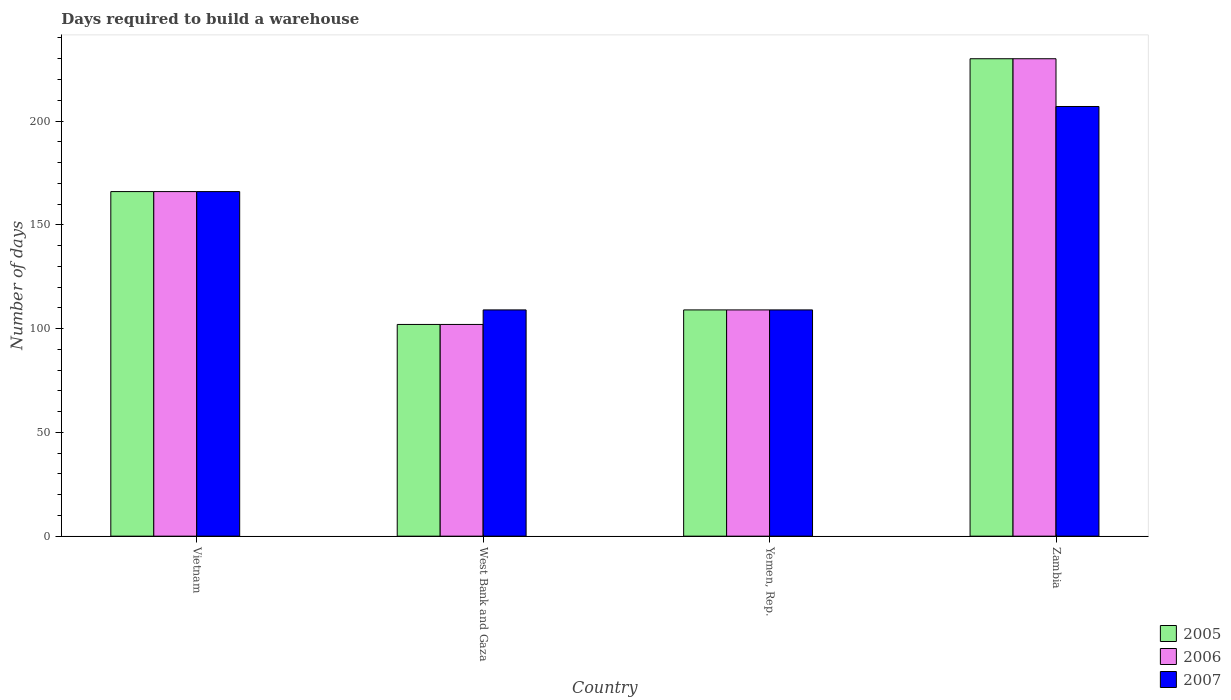How many groups of bars are there?
Ensure brevity in your answer.  4. Are the number of bars per tick equal to the number of legend labels?
Provide a succinct answer. Yes. Are the number of bars on each tick of the X-axis equal?
Provide a short and direct response. Yes. How many bars are there on the 4th tick from the right?
Provide a succinct answer. 3. What is the label of the 2nd group of bars from the left?
Make the answer very short. West Bank and Gaza. In how many cases, is the number of bars for a given country not equal to the number of legend labels?
Offer a very short reply. 0. What is the days required to build a warehouse in in 2007 in Yemen, Rep.?
Your answer should be compact. 109. Across all countries, what is the maximum days required to build a warehouse in in 2005?
Give a very brief answer. 230. Across all countries, what is the minimum days required to build a warehouse in in 2005?
Make the answer very short. 102. In which country was the days required to build a warehouse in in 2005 maximum?
Give a very brief answer. Zambia. In which country was the days required to build a warehouse in in 2005 minimum?
Make the answer very short. West Bank and Gaza. What is the total days required to build a warehouse in in 2006 in the graph?
Your answer should be very brief. 607. What is the difference between the days required to build a warehouse in in 2005 in West Bank and Gaza and that in Zambia?
Keep it short and to the point. -128. What is the average days required to build a warehouse in in 2005 per country?
Your response must be concise. 151.75. In how many countries, is the days required to build a warehouse in in 2007 greater than 180 days?
Give a very brief answer. 1. What is the ratio of the days required to build a warehouse in in 2006 in West Bank and Gaza to that in Yemen, Rep.?
Offer a very short reply. 0.94. What is the difference between the highest and the second highest days required to build a warehouse in in 2007?
Ensure brevity in your answer.  -57. What is the difference between the highest and the lowest days required to build a warehouse in in 2006?
Provide a short and direct response. 128. In how many countries, is the days required to build a warehouse in in 2005 greater than the average days required to build a warehouse in in 2005 taken over all countries?
Give a very brief answer. 2. Is it the case that in every country, the sum of the days required to build a warehouse in in 2005 and days required to build a warehouse in in 2007 is greater than the days required to build a warehouse in in 2006?
Offer a very short reply. Yes. Does the graph contain any zero values?
Give a very brief answer. No. How many legend labels are there?
Make the answer very short. 3. How are the legend labels stacked?
Your response must be concise. Vertical. What is the title of the graph?
Your response must be concise. Days required to build a warehouse. Does "1975" appear as one of the legend labels in the graph?
Provide a short and direct response. No. What is the label or title of the Y-axis?
Offer a very short reply. Number of days. What is the Number of days of 2005 in Vietnam?
Your answer should be very brief. 166. What is the Number of days of 2006 in Vietnam?
Provide a short and direct response. 166. What is the Number of days in 2007 in Vietnam?
Provide a succinct answer. 166. What is the Number of days in 2005 in West Bank and Gaza?
Make the answer very short. 102. What is the Number of days of 2006 in West Bank and Gaza?
Provide a succinct answer. 102. What is the Number of days in 2007 in West Bank and Gaza?
Offer a terse response. 109. What is the Number of days in 2005 in Yemen, Rep.?
Give a very brief answer. 109. What is the Number of days in 2006 in Yemen, Rep.?
Make the answer very short. 109. What is the Number of days of 2007 in Yemen, Rep.?
Your answer should be compact. 109. What is the Number of days of 2005 in Zambia?
Provide a short and direct response. 230. What is the Number of days of 2006 in Zambia?
Offer a very short reply. 230. What is the Number of days of 2007 in Zambia?
Give a very brief answer. 207. Across all countries, what is the maximum Number of days in 2005?
Offer a terse response. 230. Across all countries, what is the maximum Number of days in 2006?
Your answer should be compact. 230. Across all countries, what is the maximum Number of days of 2007?
Ensure brevity in your answer.  207. Across all countries, what is the minimum Number of days in 2005?
Your answer should be very brief. 102. Across all countries, what is the minimum Number of days of 2006?
Offer a terse response. 102. Across all countries, what is the minimum Number of days in 2007?
Your response must be concise. 109. What is the total Number of days in 2005 in the graph?
Make the answer very short. 607. What is the total Number of days in 2006 in the graph?
Offer a terse response. 607. What is the total Number of days of 2007 in the graph?
Keep it short and to the point. 591. What is the difference between the Number of days in 2005 in Vietnam and that in West Bank and Gaza?
Keep it short and to the point. 64. What is the difference between the Number of days in 2006 in Vietnam and that in West Bank and Gaza?
Your response must be concise. 64. What is the difference between the Number of days in 2007 in Vietnam and that in West Bank and Gaza?
Your response must be concise. 57. What is the difference between the Number of days in 2005 in Vietnam and that in Yemen, Rep.?
Your answer should be very brief. 57. What is the difference between the Number of days in 2005 in Vietnam and that in Zambia?
Make the answer very short. -64. What is the difference between the Number of days of 2006 in Vietnam and that in Zambia?
Keep it short and to the point. -64. What is the difference between the Number of days in 2007 in Vietnam and that in Zambia?
Your answer should be compact. -41. What is the difference between the Number of days in 2006 in West Bank and Gaza and that in Yemen, Rep.?
Provide a succinct answer. -7. What is the difference between the Number of days of 2005 in West Bank and Gaza and that in Zambia?
Provide a short and direct response. -128. What is the difference between the Number of days of 2006 in West Bank and Gaza and that in Zambia?
Your answer should be compact. -128. What is the difference between the Number of days in 2007 in West Bank and Gaza and that in Zambia?
Offer a terse response. -98. What is the difference between the Number of days of 2005 in Yemen, Rep. and that in Zambia?
Your response must be concise. -121. What is the difference between the Number of days in 2006 in Yemen, Rep. and that in Zambia?
Your answer should be very brief. -121. What is the difference between the Number of days of 2007 in Yemen, Rep. and that in Zambia?
Make the answer very short. -98. What is the difference between the Number of days in 2005 in Vietnam and the Number of days in 2006 in West Bank and Gaza?
Keep it short and to the point. 64. What is the difference between the Number of days of 2005 in Vietnam and the Number of days of 2007 in Yemen, Rep.?
Ensure brevity in your answer.  57. What is the difference between the Number of days in 2006 in Vietnam and the Number of days in 2007 in Yemen, Rep.?
Your answer should be very brief. 57. What is the difference between the Number of days in 2005 in Vietnam and the Number of days in 2006 in Zambia?
Keep it short and to the point. -64. What is the difference between the Number of days in 2005 in Vietnam and the Number of days in 2007 in Zambia?
Ensure brevity in your answer.  -41. What is the difference between the Number of days in 2006 in Vietnam and the Number of days in 2007 in Zambia?
Your answer should be compact. -41. What is the difference between the Number of days in 2005 in West Bank and Gaza and the Number of days in 2007 in Yemen, Rep.?
Keep it short and to the point. -7. What is the difference between the Number of days in 2005 in West Bank and Gaza and the Number of days in 2006 in Zambia?
Make the answer very short. -128. What is the difference between the Number of days in 2005 in West Bank and Gaza and the Number of days in 2007 in Zambia?
Ensure brevity in your answer.  -105. What is the difference between the Number of days of 2006 in West Bank and Gaza and the Number of days of 2007 in Zambia?
Offer a terse response. -105. What is the difference between the Number of days in 2005 in Yemen, Rep. and the Number of days in 2006 in Zambia?
Keep it short and to the point. -121. What is the difference between the Number of days of 2005 in Yemen, Rep. and the Number of days of 2007 in Zambia?
Ensure brevity in your answer.  -98. What is the difference between the Number of days in 2006 in Yemen, Rep. and the Number of days in 2007 in Zambia?
Offer a very short reply. -98. What is the average Number of days of 2005 per country?
Provide a short and direct response. 151.75. What is the average Number of days in 2006 per country?
Keep it short and to the point. 151.75. What is the average Number of days in 2007 per country?
Your answer should be very brief. 147.75. What is the difference between the Number of days of 2005 and Number of days of 2007 in Vietnam?
Offer a terse response. 0. What is the difference between the Number of days in 2006 and Number of days in 2007 in West Bank and Gaza?
Offer a terse response. -7. What is the difference between the Number of days of 2006 and Number of days of 2007 in Yemen, Rep.?
Offer a very short reply. 0. What is the difference between the Number of days of 2005 and Number of days of 2007 in Zambia?
Provide a short and direct response. 23. What is the ratio of the Number of days of 2005 in Vietnam to that in West Bank and Gaza?
Offer a very short reply. 1.63. What is the ratio of the Number of days in 2006 in Vietnam to that in West Bank and Gaza?
Keep it short and to the point. 1.63. What is the ratio of the Number of days in 2007 in Vietnam to that in West Bank and Gaza?
Your answer should be very brief. 1.52. What is the ratio of the Number of days of 2005 in Vietnam to that in Yemen, Rep.?
Ensure brevity in your answer.  1.52. What is the ratio of the Number of days in 2006 in Vietnam to that in Yemen, Rep.?
Keep it short and to the point. 1.52. What is the ratio of the Number of days in 2007 in Vietnam to that in Yemen, Rep.?
Provide a succinct answer. 1.52. What is the ratio of the Number of days in 2005 in Vietnam to that in Zambia?
Ensure brevity in your answer.  0.72. What is the ratio of the Number of days of 2006 in Vietnam to that in Zambia?
Offer a very short reply. 0.72. What is the ratio of the Number of days of 2007 in Vietnam to that in Zambia?
Provide a short and direct response. 0.8. What is the ratio of the Number of days of 2005 in West Bank and Gaza to that in Yemen, Rep.?
Provide a succinct answer. 0.94. What is the ratio of the Number of days of 2006 in West Bank and Gaza to that in Yemen, Rep.?
Ensure brevity in your answer.  0.94. What is the ratio of the Number of days in 2005 in West Bank and Gaza to that in Zambia?
Your answer should be very brief. 0.44. What is the ratio of the Number of days of 2006 in West Bank and Gaza to that in Zambia?
Provide a short and direct response. 0.44. What is the ratio of the Number of days in 2007 in West Bank and Gaza to that in Zambia?
Make the answer very short. 0.53. What is the ratio of the Number of days in 2005 in Yemen, Rep. to that in Zambia?
Give a very brief answer. 0.47. What is the ratio of the Number of days of 2006 in Yemen, Rep. to that in Zambia?
Ensure brevity in your answer.  0.47. What is the ratio of the Number of days in 2007 in Yemen, Rep. to that in Zambia?
Offer a terse response. 0.53. What is the difference between the highest and the second highest Number of days of 2006?
Keep it short and to the point. 64. What is the difference between the highest and the second highest Number of days of 2007?
Offer a very short reply. 41. What is the difference between the highest and the lowest Number of days in 2005?
Ensure brevity in your answer.  128. What is the difference between the highest and the lowest Number of days in 2006?
Ensure brevity in your answer.  128. What is the difference between the highest and the lowest Number of days of 2007?
Offer a very short reply. 98. 